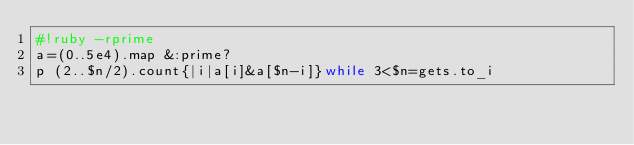Convert code to text. <code><loc_0><loc_0><loc_500><loc_500><_Ruby_>#!ruby -rprime
a=(0..5e4).map &:prime?
p (2..$n/2).count{|i|a[i]&a[$n-i]}while 3<$n=gets.to_i</code> 